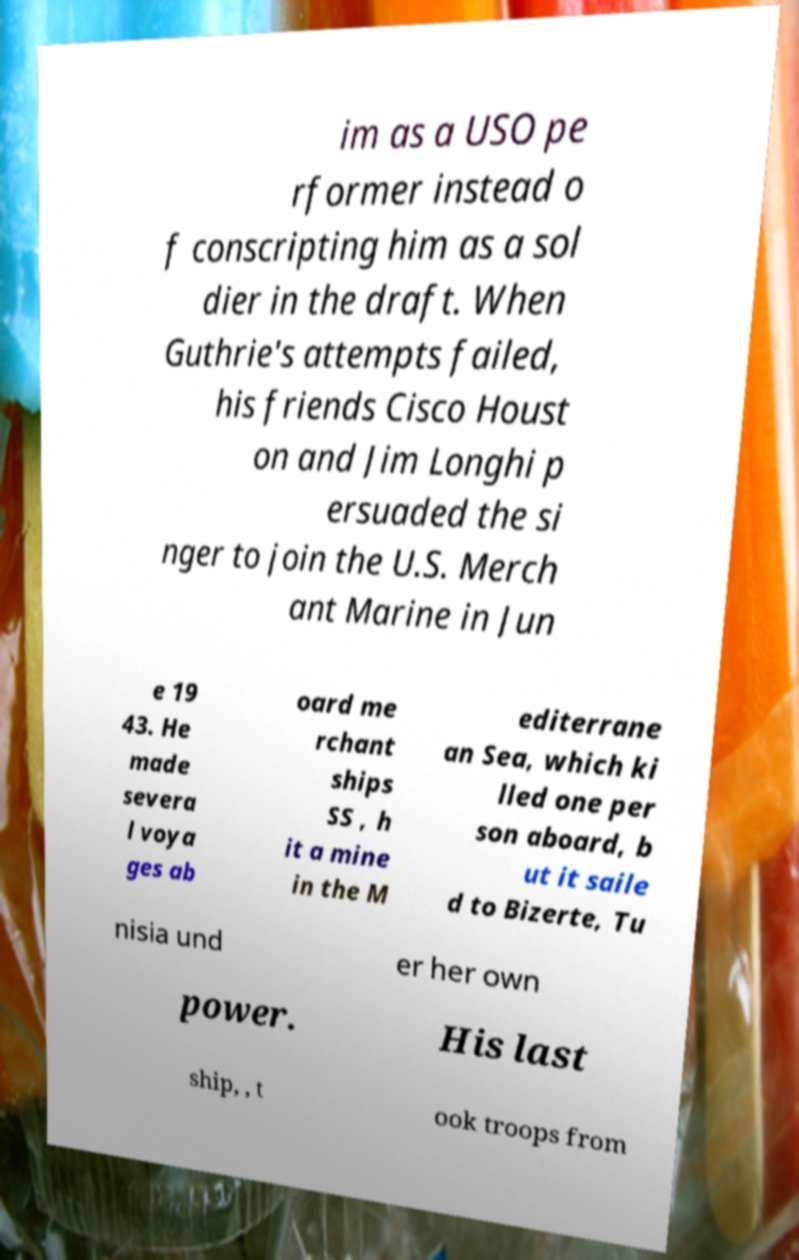For documentation purposes, I need the text within this image transcribed. Could you provide that? im as a USO pe rformer instead o f conscripting him as a sol dier in the draft. When Guthrie's attempts failed, his friends Cisco Houst on and Jim Longhi p ersuaded the si nger to join the U.S. Merch ant Marine in Jun e 19 43. He made severa l voya ges ab oard me rchant ships SS , h it a mine in the M editerrane an Sea, which ki lled one per son aboard, b ut it saile d to Bizerte, Tu nisia und er her own power. His last ship, , t ook troops from 